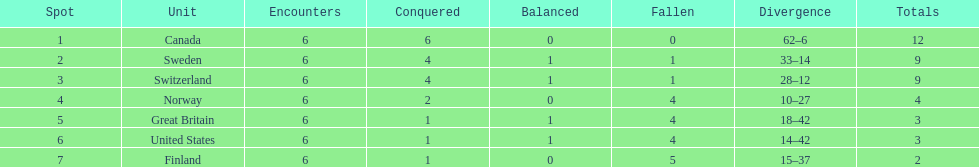Which country performed better during the 1951 world ice hockey championships, switzerland or great britain? Switzerland. 